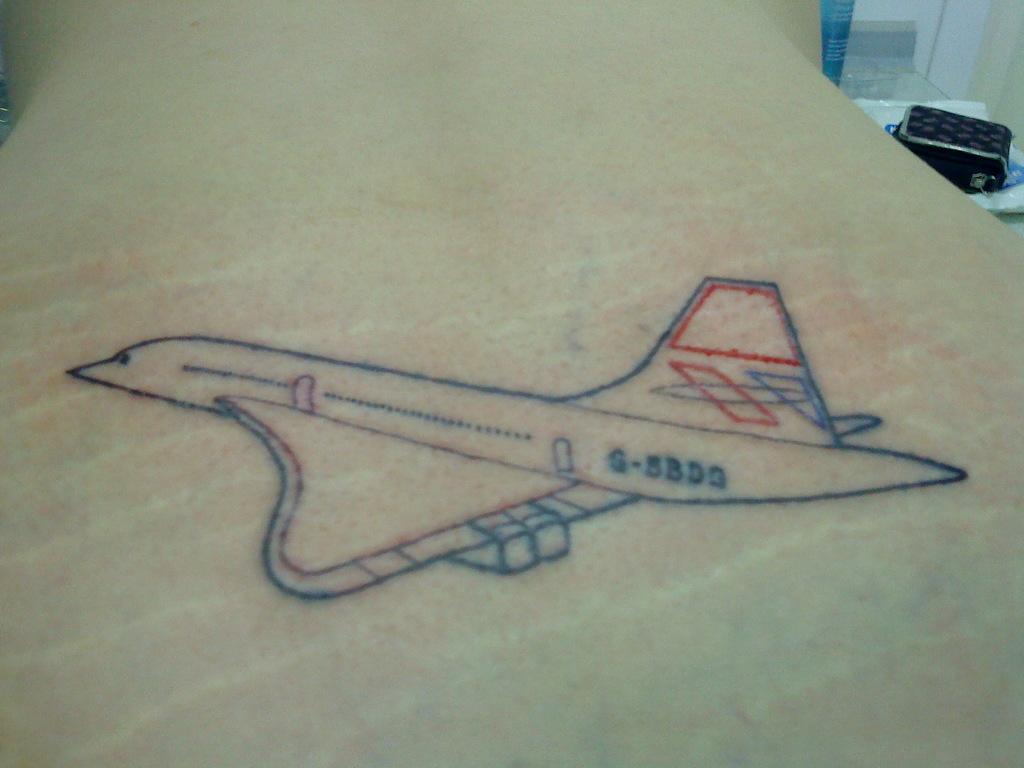What is the number on the plane?
Ensure brevity in your answer.  S-5bdg. What is the first letter on the plane?
Offer a terse response. G. 